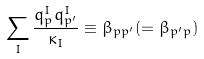<formula> <loc_0><loc_0><loc_500><loc_500>\sum _ { I } \frac { q _ { p } ^ { I } q _ { p ^ { \prime } } ^ { I } } { \kappa _ { I } } \equiv \beta _ { p p ^ { \prime } } ( = \beta _ { p ^ { \prime } p } )</formula> 